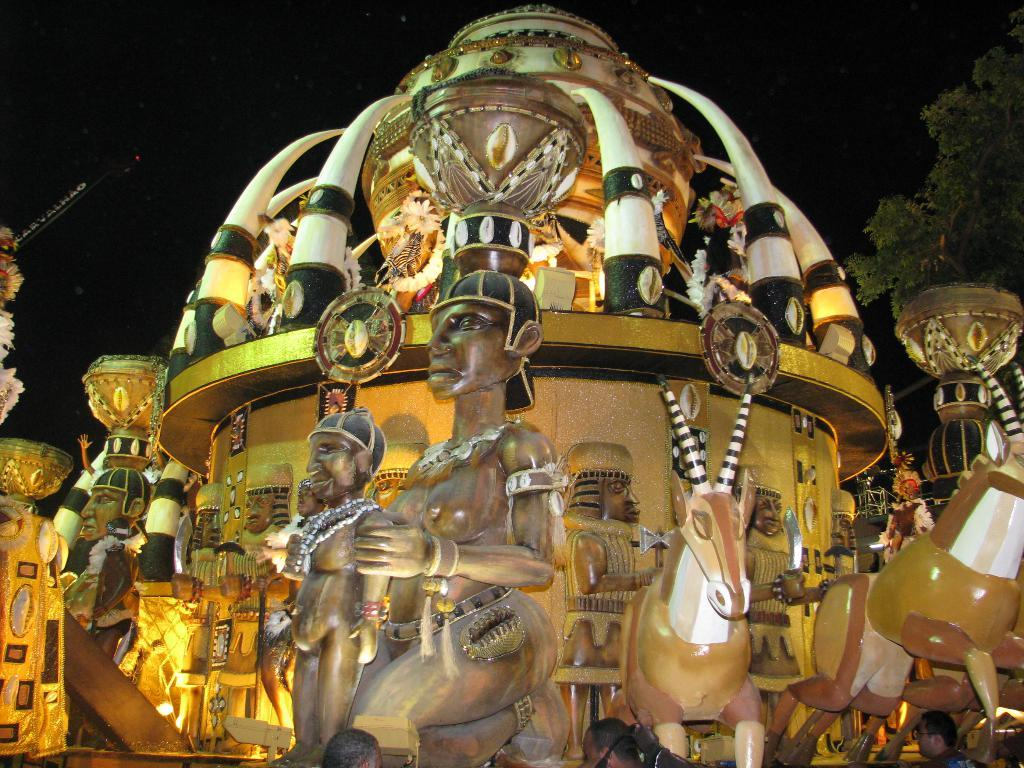What type of objects can be seen in the image? There are statues and some objects visible in the image. What natural element is present in the image? There is a tree in the image. How would you describe the background of the image? The background of the image is dark. What type of hat is the mountain wearing in the image? There is no mountain or hat present in the image. What type of wood is used to create the statues in the image? The provided facts do not mention the type of wood used to create the statues, so we cannot determine that information from the image. 